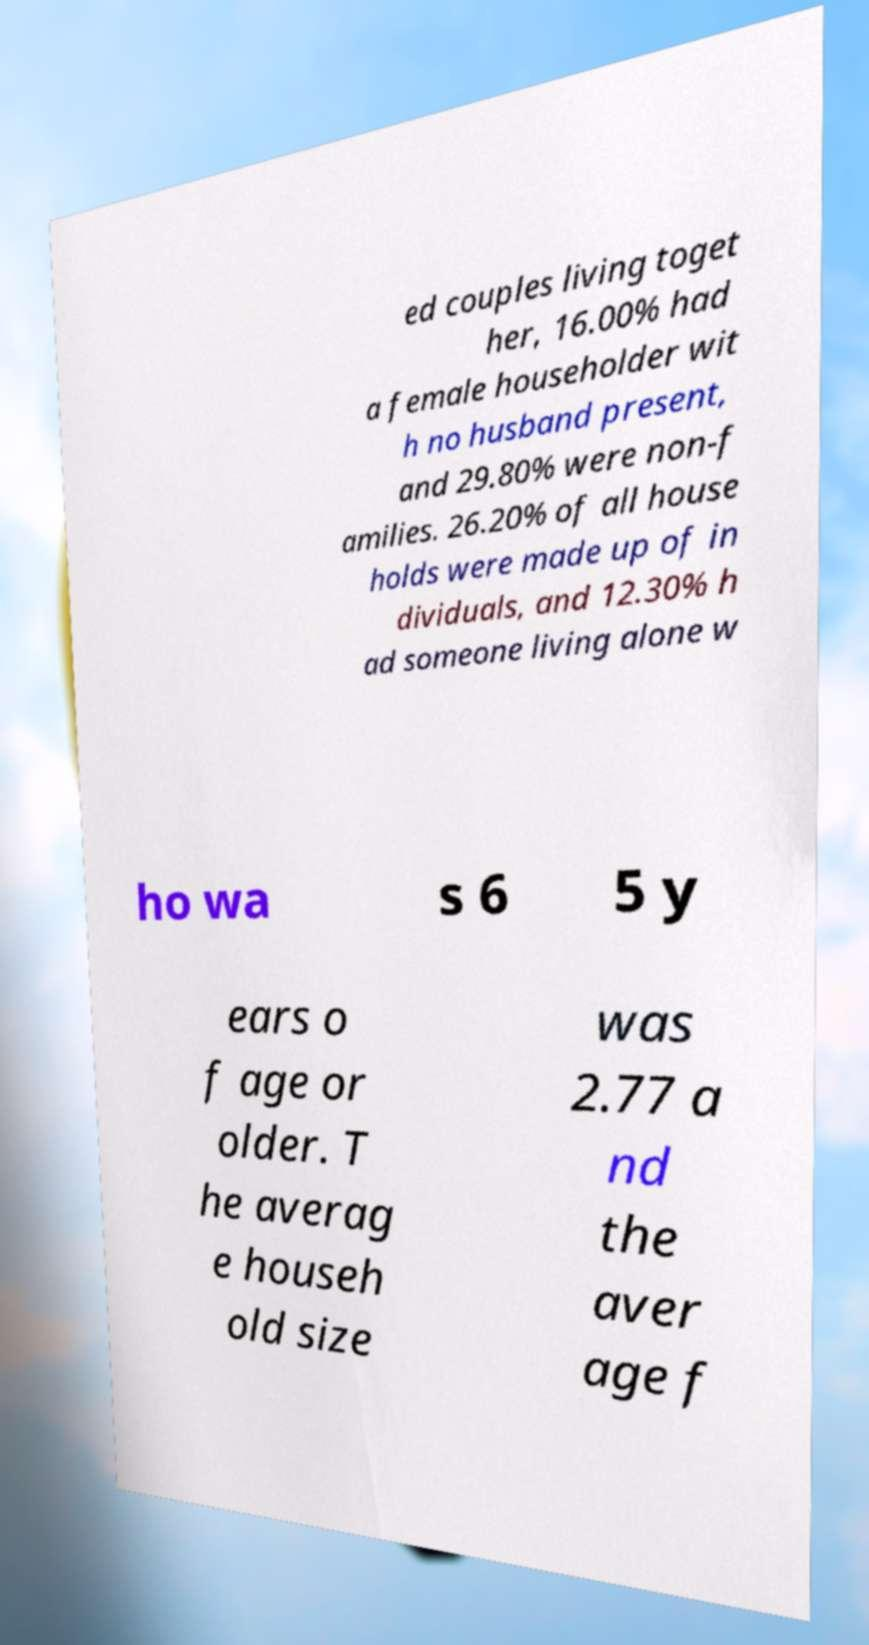I need the written content from this picture converted into text. Can you do that? ed couples living toget her, 16.00% had a female householder wit h no husband present, and 29.80% were non-f amilies. 26.20% of all house holds were made up of in dividuals, and 12.30% h ad someone living alone w ho wa s 6 5 y ears o f age or older. T he averag e househ old size was 2.77 a nd the aver age f 